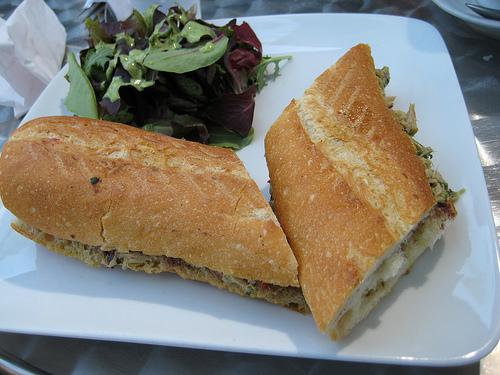Question: how many plates are shown?
Choices:
A. Eight.
B. Two.
C. Five.
D. One.
Answer with the letter. Answer: D Question: where is the sandwich?
Choices:
A. On plate.
B. On the table.
C. In the bowl.
D. On the waiters tray.
Answer with the letter. Answer: A Question: how many sandwich halves are shown?
Choices:
A. Four.
B. Six.
C. Eight.
D. Two.
Answer with the letter. Answer: D Question: what color is the bread?
Choices:
A. Grey.
B. Blue.
C. White.
D. Brown.
Answer with the letter. Answer: D 